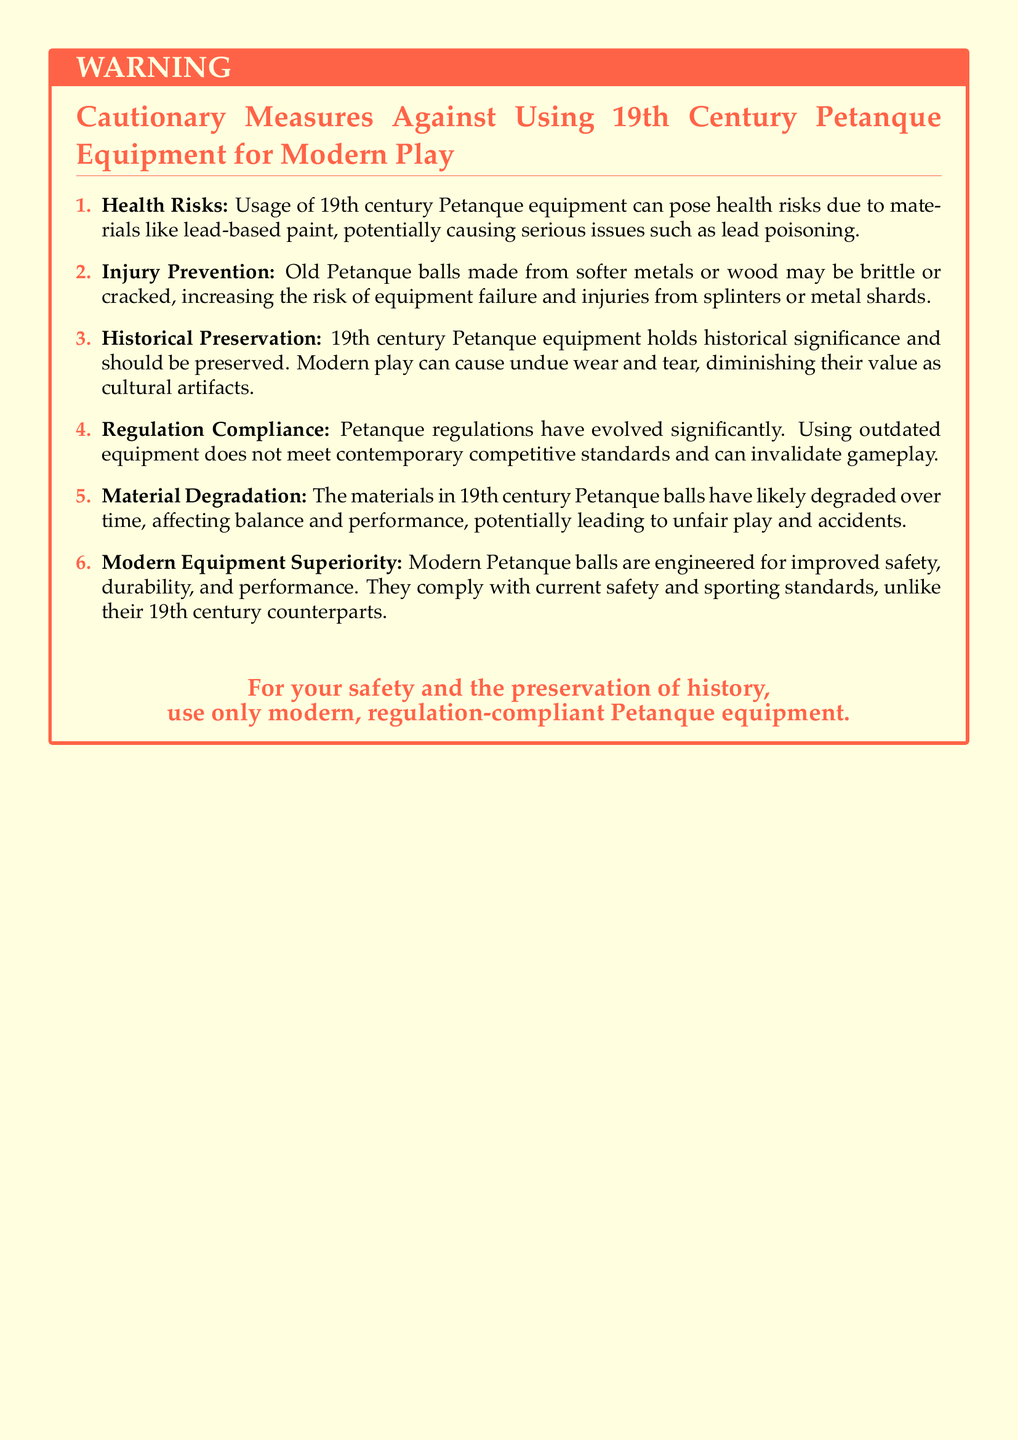What are the health risks of using old Petanque equipment? The document mentions that usage of 19th century Petanque equipment can pose health risks such as lead poisoning due to materials like lead-based paint.
Answer: Lead poisoning What is a potential injury risk associated with old Petanque balls? The document states that old Petanque balls may be brittle or cracked, increasing the risk of injuries from splinters or metal shards.
Answer: Splinters What should be preserved according to the document? The document highlights the importance of preserving 19th century Petanque equipment due to their historical significance.
Answer: 19th century Petanque equipment What has evolved significantly in Petanque according to the warning label? The document notes that Petanque regulations have evolved significantly, which suggests changes in rules and standards over time.
Answer: Regulations What is recommended for safety and preservation? The document advises users to use only modern, regulation-compliant Petanque equipment for safety and historical preservation.
Answer: Modern equipment What is a key reason against using 19th century Petanque equipment in modern play? The document states that the materials in 19th century Petanque balls have likely degraded, affecting balance and performance.
Answer: Degradation What type of materials were used in 19th century Petanque balls? The document indicates that 19th century Petanque balls were made from softer metals or wood.
Answer: Softer metals or wood What performance advantage do modern Petanque balls have? The document states that modern Petanque balls are engineered for improved safety, durability, and performance.
Answer: Improved safety and durability 